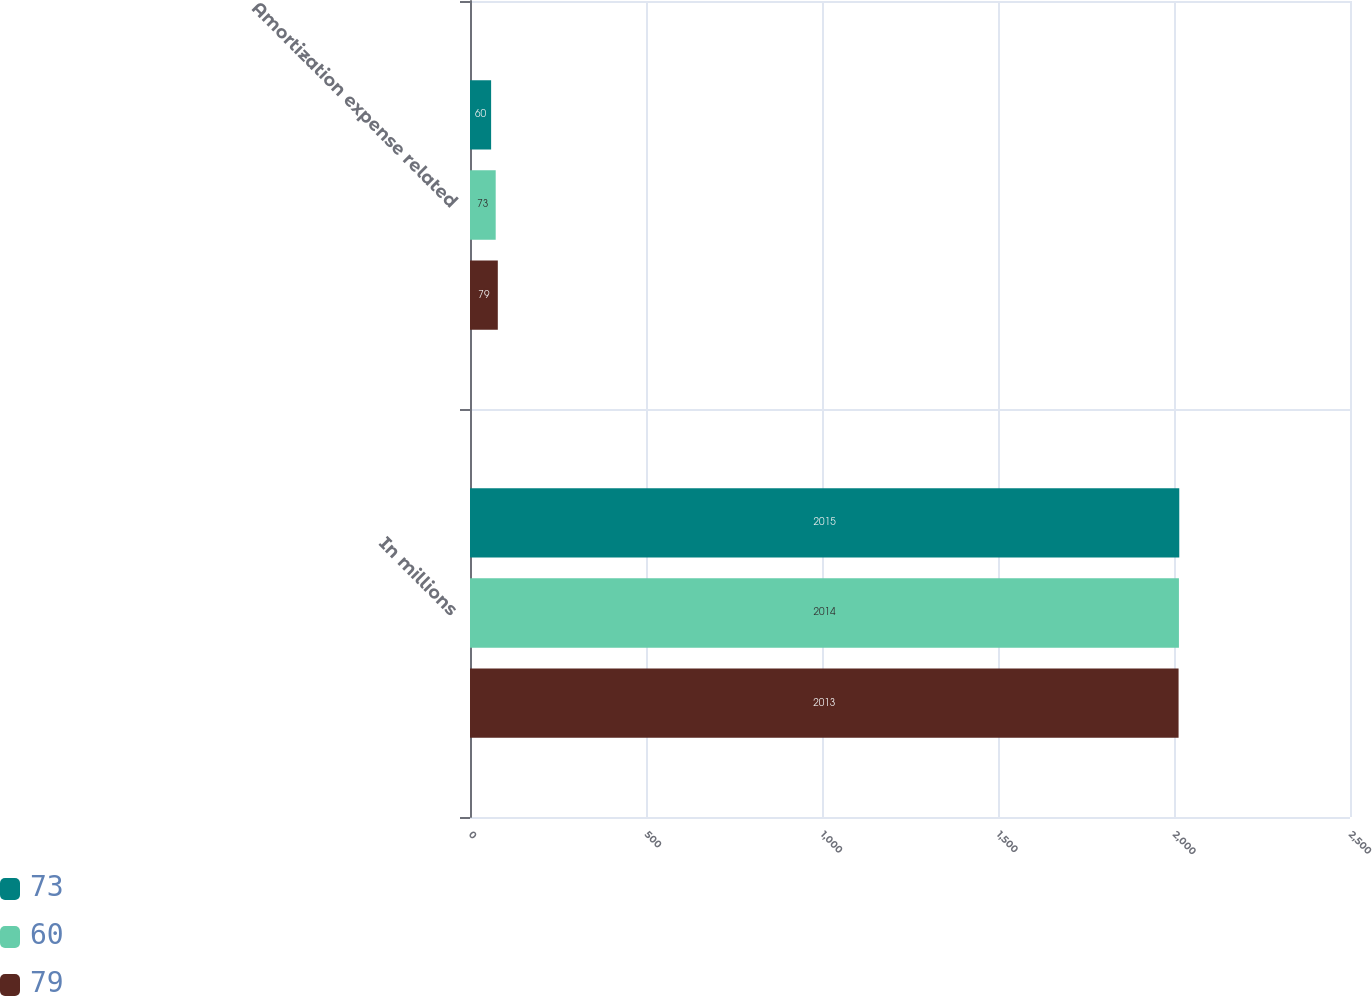Convert chart. <chart><loc_0><loc_0><loc_500><loc_500><stacked_bar_chart><ecel><fcel>In millions<fcel>Amortization expense related<nl><fcel>73<fcel>2015<fcel>60<nl><fcel>60<fcel>2014<fcel>73<nl><fcel>79<fcel>2013<fcel>79<nl></chart> 